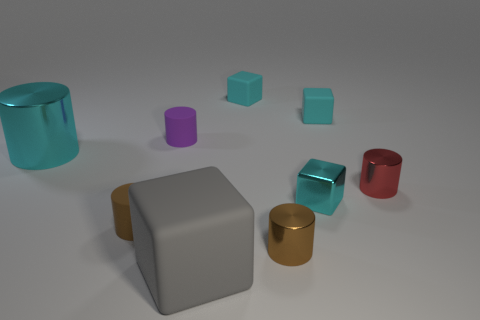There is a brown cylinder on the left side of the gray matte thing that is in front of the big cyan shiny thing; what is its material? The material of the brown cylinder appears to be ceramic, characterized by its solid form and non-reflective, matte finish similar to clay-based items. 